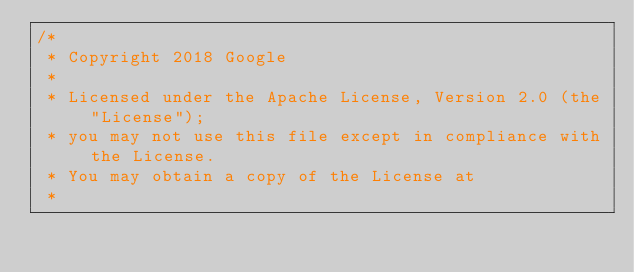<code> <loc_0><loc_0><loc_500><loc_500><_C++_>/*
 * Copyright 2018 Google
 *
 * Licensed under the Apache License, Version 2.0 (the "License");
 * you may not use this file except in compliance with the License.
 * You may obtain a copy of the License at
 *</code> 